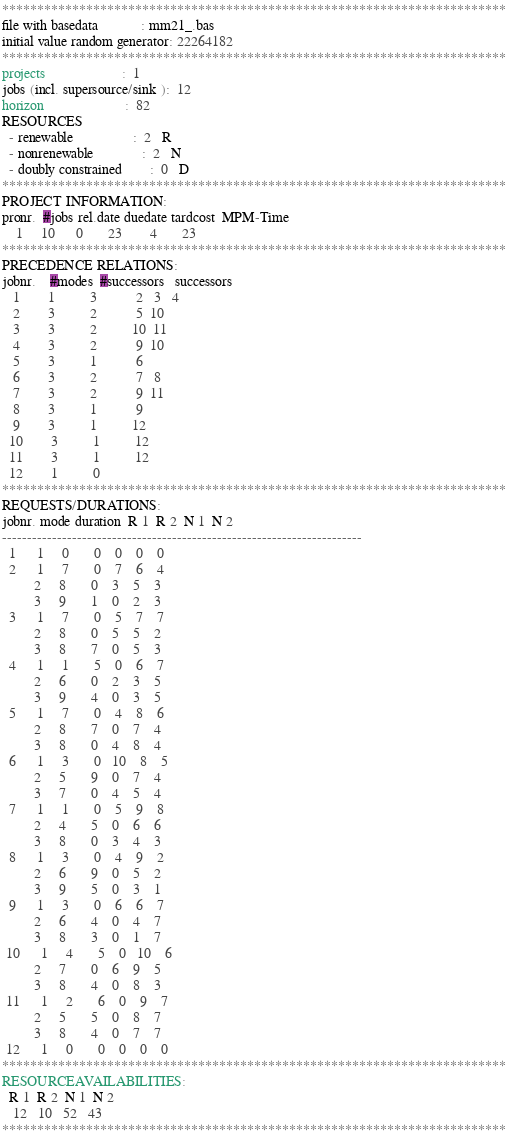Convert code to text. <code><loc_0><loc_0><loc_500><loc_500><_ObjectiveC_>************************************************************************
file with basedata            : mm21_.bas
initial value random generator: 22264182
************************************************************************
projects                      :  1
jobs (incl. supersource/sink ):  12
horizon                       :  82
RESOURCES
  - renewable                 :  2   R
  - nonrenewable              :  2   N
  - doubly constrained        :  0   D
************************************************************************
PROJECT INFORMATION:
pronr.  #jobs rel.date duedate tardcost  MPM-Time
    1     10      0       23        4       23
************************************************************************
PRECEDENCE RELATIONS:
jobnr.    #modes  #successors   successors
   1        1          3           2   3   4
   2        3          2           5  10
   3        3          2          10  11
   4        3          2           9  10
   5        3          1           6
   6        3          2           7   8
   7        3          2           9  11
   8        3          1           9
   9        3          1          12
  10        3          1          12
  11        3          1          12
  12        1          0        
************************************************************************
REQUESTS/DURATIONS:
jobnr. mode duration  R 1  R 2  N 1  N 2
------------------------------------------------------------------------
  1      1     0       0    0    0    0
  2      1     7       0    7    6    4
         2     8       0    3    5    3
         3     9       1    0    2    3
  3      1     7       0    5    7    7
         2     8       0    5    5    2
         3     8       7    0    5    3
  4      1     1       5    0    6    7
         2     6       0    2    3    5
         3     9       4    0    3    5
  5      1     7       0    4    8    6
         2     8       7    0    7    4
         3     8       0    4    8    4
  6      1     3       0   10    8    5
         2     5       9    0    7    4
         3     7       0    4    5    4
  7      1     1       0    5    9    8
         2     4       5    0    6    6
         3     8       0    3    4    3
  8      1     3       0    4    9    2
         2     6       9    0    5    2
         3     9       5    0    3    1
  9      1     3       0    6    6    7
         2     6       4    0    4    7
         3     8       3    0    1    7
 10      1     4       5    0   10    6
         2     7       0    6    9    5
         3     8       4    0    8    3
 11      1     2       6    0    9    7
         2     5       5    0    8    7
         3     8       4    0    7    7
 12      1     0       0    0    0    0
************************************************************************
RESOURCEAVAILABILITIES:
  R 1  R 2  N 1  N 2
   12   10   52   43
************************************************************************
</code> 